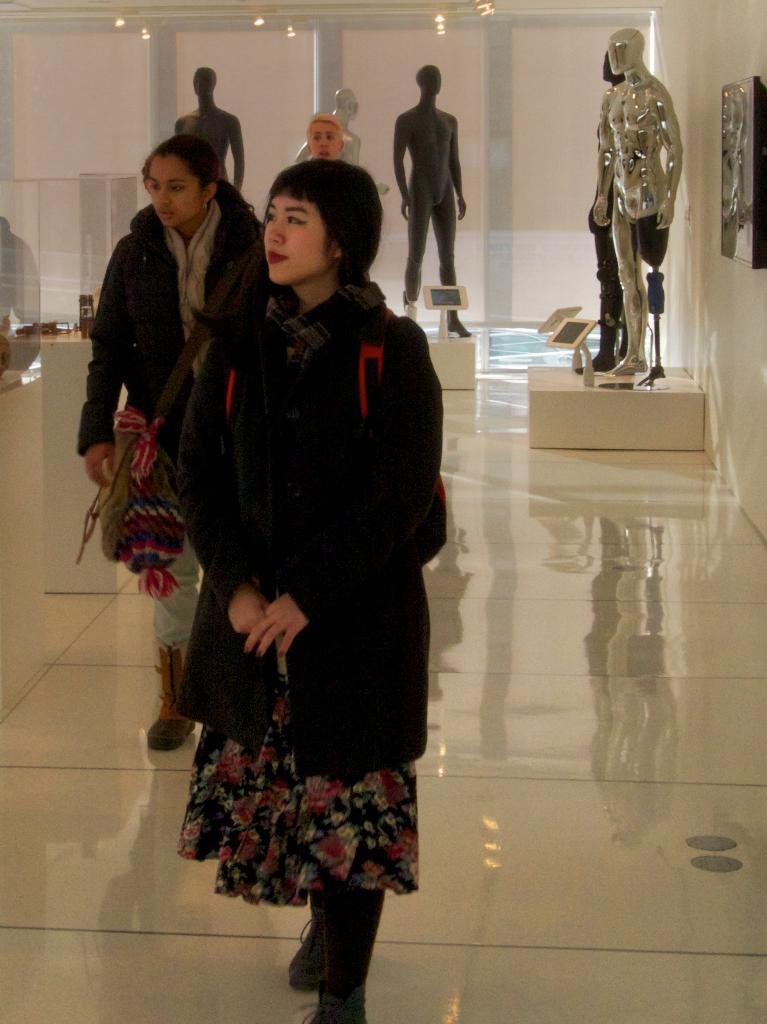What can be seen in the image involving human figures? There are people standing in the image. What other figures are present in the image? There are mannequins in the image. What is attached to the wall in the image? There is an object attached to the wall in the image. What type of illumination is present in the image? There are lights in the image. What other objects can be seen in the image? There are other objects present in the image. Where is the cow located in the image? There is no cow present in the image. What type of playground equipment can be seen in the image? There is no playground equipment present in the image. 